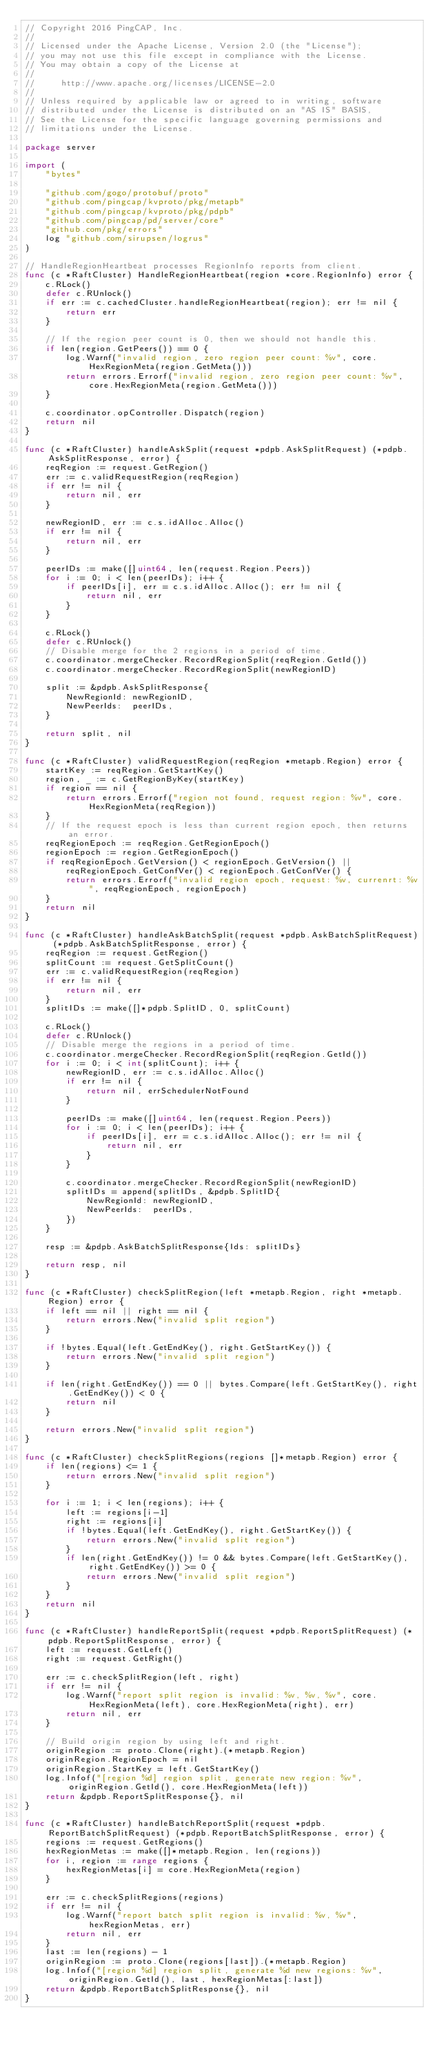Convert code to text. <code><loc_0><loc_0><loc_500><loc_500><_Go_>// Copyright 2016 PingCAP, Inc.
//
// Licensed under the Apache License, Version 2.0 (the "License");
// you may not use this file except in compliance with the License.
// You may obtain a copy of the License at
//
//     http://www.apache.org/licenses/LICENSE-2.0
//
// Unless required by applicable law or agreed to in writing, software
// distributed under the License is distributed on an "AS IS" BASIS,
// See the License for the specific language governing permissions and
// limitations under the License.

package server

import (
	"bytes"

	"github.com/gogo/protobuf/proto"
	"github.com/pingcap/kvproto/pkg/metapb"
	"github.com/pingcap/kvproto/pkg/pdpb"
	"github.com/pingcap/pd/server/core"
	"github.com/pkg/errors"
	log "github.com/sirupsen/logrus"
)

// HandleRegionHeartbeat processes RegionInfo reports from client.
func (c *RaftCluster) HandleRegionHeartbeat(region *core.RegionInfo) error {
	c.RLock()
	defer c.RUnlock()
	if err := c.cachedCluster.handleRegionHeartbeat(region); err != nil {
		return err
	}

	// If the region peer count is 0, then we should not handle this.
	if len(region.GetPeers()) == 0 {
		log.Warnf("invalid region, zero region peer count: %v", core.HexRegionMeta(region.GetMeta()))
		return errors.Errorf("invalid region, zero region peer count: %v", core.HexRegionMeta(region.GetMeta()))
	}

	c.coordinator.opController.Dispatch(region)
	return nil
}

func (c *RaftCluster) handleAskSplit(request *pdpb.AskSplitRequest) (*pdpb.AskSplitResponse, error) {
	reqRegion := request.GetRegion()
	err := c.validRequestRegion(reqRegion)
	if err != nil {
		return nil, err
	}

	newRegionID, err := c.s.idAlloc.Alloc()
	if err != nil {
		return nil, err
	}

	peerIDs := make([]uint64, len(request.Region.Peers))
	for i := 0; i < len(peerIDs); i++ {
		if peerIDs[i], err = c.s.idAlloc.Alloc(); err != nil {
			return nil, err
		}
	}

	c.RLock()
	defer c.RUnlock()
	// Disable merge for the 2 regions in a period of time.
	c.coordinator.mergeChecker.RecordRegionSplit(reqRegion.GetId())
	c.coordinator.mergeChecker.RecordRegionSplit(newRegionID)

	split := &pdpb.AskSplitResponse{
		NewRegionId: newRegionID,
		NewPeerIds:  peerIDs,
	}

	return split, nil
}

func (c *RaftCluster) validRequestRegion(reqRegion *metapb.Region) error {
	startKey := reqRegion.GetStartKey()
	region, _ := c.GetRegionByKey(startKey)
	if region == nil {
		return errors.Errorf("region not found, request region: %v", core.HexRegionMeta(reqRegion))
	}
	// If the request epoch is less than current region epoch, then returns an error.
	reqRegionEpoch := reqRegion.GetRegionEpoch()
	regionEpoch := region.GetRegionEpoch()
	if reqRegionEpoch.GetVersion() < regionEpoch.GetVersion() ||
		reqRegionEpoch.GetConfVer() < regionEpoch.GetConfVer() {
		return errors.Errorf("invalid region epoch, request: %v, currenrt: %v", reqRegionEpoch, regionEpoch)
	}
	return nil
}

func (c *RaftCluster) handleAskBatchSplit(request *pdpb.AskBatchSplitRequest) (*pdpb.AskBatchSplitResponse, error) {
	reqRegion := request.GetRegion()
	splitCount := request.GetSplitCount()
	err := c.validRequestRegion(reqRegion)
	if err != nil {
		return nil, err
	}
	splitIDs := make([]*pdpb.SplitID, 0, splitCount)

	c.RLock()
	defer c.RUnlock()
	// Disable merge the regions in a period of time.
	c.coordinator.mergeChecker.RecordRegionSplit(reqRegion.GetId())
	for i := 0; i < int(splitCount); i++ {
		newRegionID, err := c.s.idAlloc.Alloc()
		if err != nil {
			return nil, errSchedulerNotFound
		}

		peerIDs := make([]uint64, len(request.Region.Peers))
		for i := 0; i < len(peerIDs); i++ {
			if peerIDs[i], err = c.s.idAlloc.Alloc(); err != nil {
				return nil, err
			}
		}

		c.coordinator.mergeChecker.RecordRegionSplit(newRegionID)
		splitIDs = append(splitIDs, &pdpb.SplitID{
			NewRegionId: newRegionID,
			NewPeerIds:  peerIDs,
		})
	}

	resp := &pdpb.AskBatchSplitResponse{Ids: splitIDs}

	return resp, nil
}

func (c *RaftCluster) checkSplitRegion(left *metapb.Region, right *metapb.Region) error {
	if left == nil || right == nil {
		return errors.New("invalid split region")
	}

	if !bytes.Equal(left.GetEndKey(), right.GetStartKey()) {
		return errors.New("invalid split region")
	}

	if len(right.GetEndKey()) == 0 || bytes.Compare(left.GetStartKey(), right.GetEndKey()) < 0 {
		return nil
	}

	return errors.New("invalid split region")
}

func (c *RaftCluster) checkSplitRegions(regions []*metapb.Region) error {
	if len(regions) <= 1 {
		return errors.New("invalid split region")
	}

	for i := 1; i < len(regions); i++ {
		left := regions[i-1]
		right := regions[i]
		if !bytes.Equal(left.GetEndKey(), right.GetStartKey()) {
			return errors.New("invalid split region")
		}
		if len(right.GetEndKey()) != 0 && bytes.Compare(left.GetStartKey(), right.GetEndKey()) >= 0 {
			return errors.New("invalid split region")
		}
	}
	return nil
}

func (c *RaftCluster) handleReportSplit(request *pdpb.ReportSplitRequest) (*pdpb.ReportSplitResponse, error) {
	left := request.GetLeft()
	right := request.GetRight()

	err := c.checkSplitRegion(left, right)
	if err != nil {
		log.Warnf("report split region is invalid: %v, %v, %v", core.HexRegionMeta(left), core.HexRegionMeta(right), err)
		return nil, err
	}

	// Build origin region by using left and right.
	originRegion := proto.Clone(right).(*metapb.Region)
	originRegion.RegionEpoch = nil
	originRegion.StartKey = left.GetStartKey()
	log.Infof("[region %d] region split, generate new region: %v", originRegion.GetId(), core.HexRegionMeta(left))
	return &pdpb.ReportSplitResponse{}, nil
}

func (c *RaftCluster) handleBatchReportSplit(request *pdpb.ReportBatchSplitRequest) (*pdpb.ReportBatchSplitResponse, error) {
	regions := request.GetRegions()
	hexRegionMetas := make([]*metapb.Region, len(regions))
	for i, region := range regions {
		hexRegionMetas[i] = core.HexRegionMeta(region)
	}

	err := c.checkSplitRegions(regions)
	if err != nil {
		log.Warnf("report batch split region is invalid: %v, %v", hexRegionMetas, err)
		return nil, err
	}
	last := len(regions) - 1
	originRegion := proto.Clone(regions[last]).(*metapb.Region)
	log.Infof("[region %d] region split, generate %d new regions: %v", originRegion.GetId(), last, hexRegionMetas[:last])
	return &pdpb.ReportBatchSplitResponse{}, nil
}
</code> 